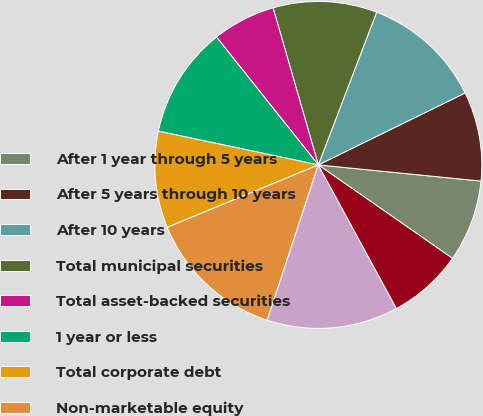Convert chart to OTSL. <chart><loc_0><loc_0><loc_500><loc_500><pie_chart><fcel>After 1 year through 5 years<fcel>After 5 years through 10 years<fcel>After 10 years<fcel>Total municipal securities<fcel>Total asset-backed securities<fcel>1 year or less<fcel>Total corporate debt<fcel>Non-marketable equity<fcel>Total other<fcel>Total available-for-sale and<nl><fcel>8.11%<fcel>8.83%<fcel>11.95%<fcel>10.27%<fcel>6.24%<fcel>10.99%<fcel>9.55%<fcel>13.71%<fcel>12.99%<fcel>7.39%<nl></chart> 